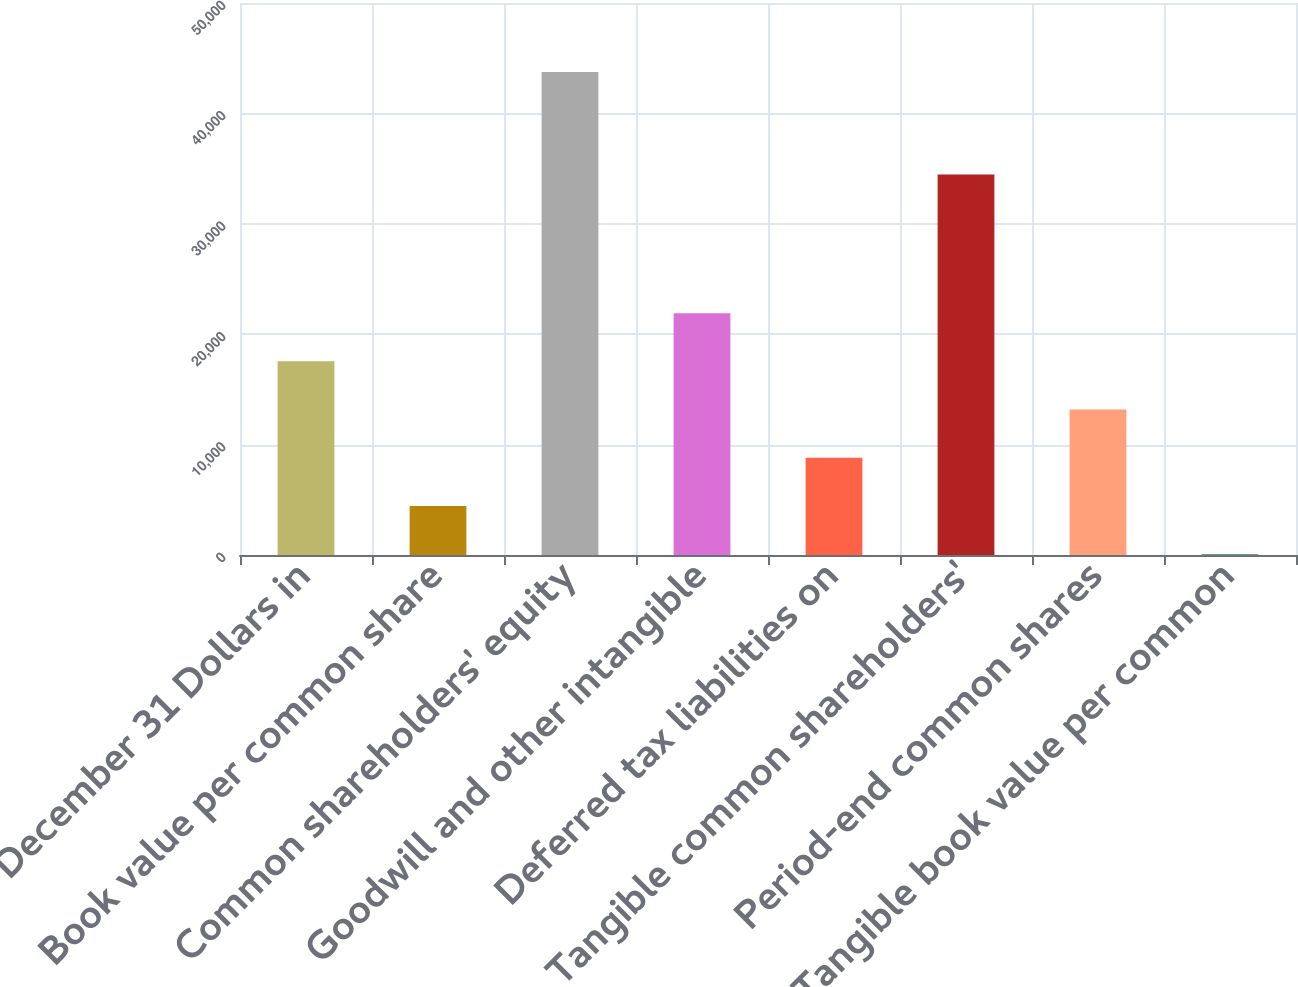<chart> <loc_0><loc_0><loc_500><loc_500><bar_chart><fcel>December 31 Dollars in<fcel>Book value per common share<fcel>Common shareholders' equity<fcel>Goodwill and other intangible<fcel>Deferred tax liabilities on<fcel>Tangible common shareholders'<fcel>Period-end common shares<fcel>Tangible book value per common<nl><fcel>17542.1<fcel>4442.08<fcel>43742<fcel>21908.7<fcel>8808.74<fcel>34465<fcel>13175.4<fcel>75.42<nl></chart> 